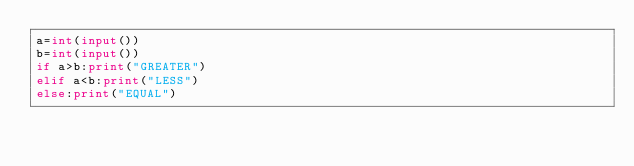Convert code to text. <code><loc_0><loc_0><loc_500><loc_500><_Python_>a=int(input())
b=int(input())
if a>b:print("GREATER")
elif a<b:print("LESS")
else:print("EQUAL")</code> 